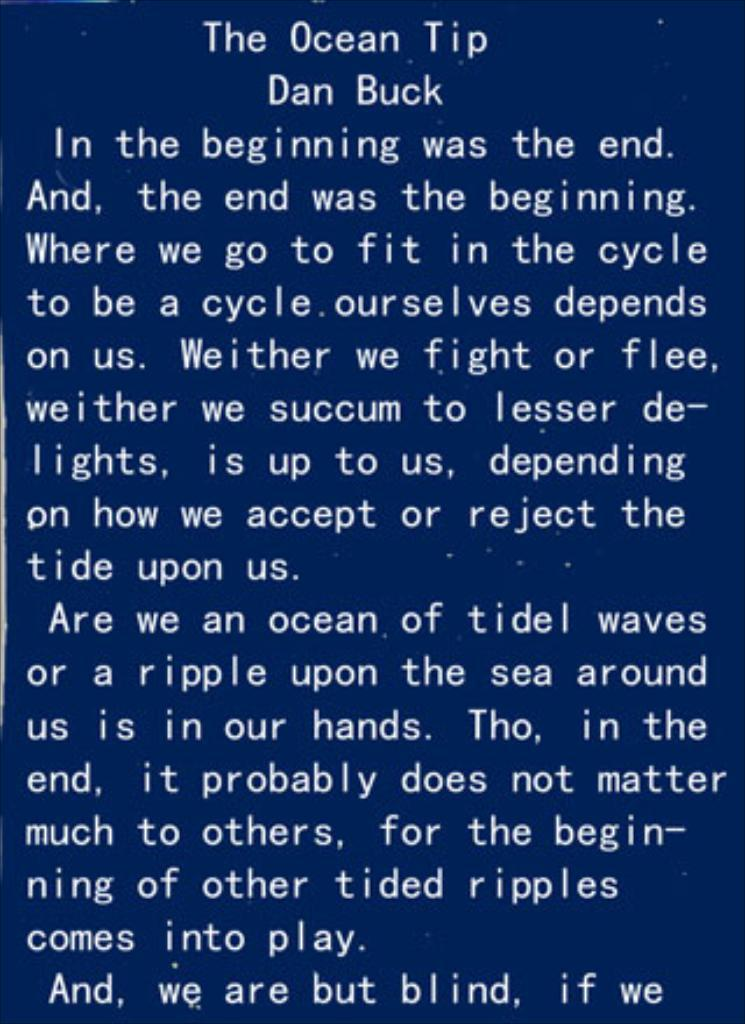<image>
Share a concise interpretation of the image provided. A passage from The Ocean Tip by Dan Buck. 